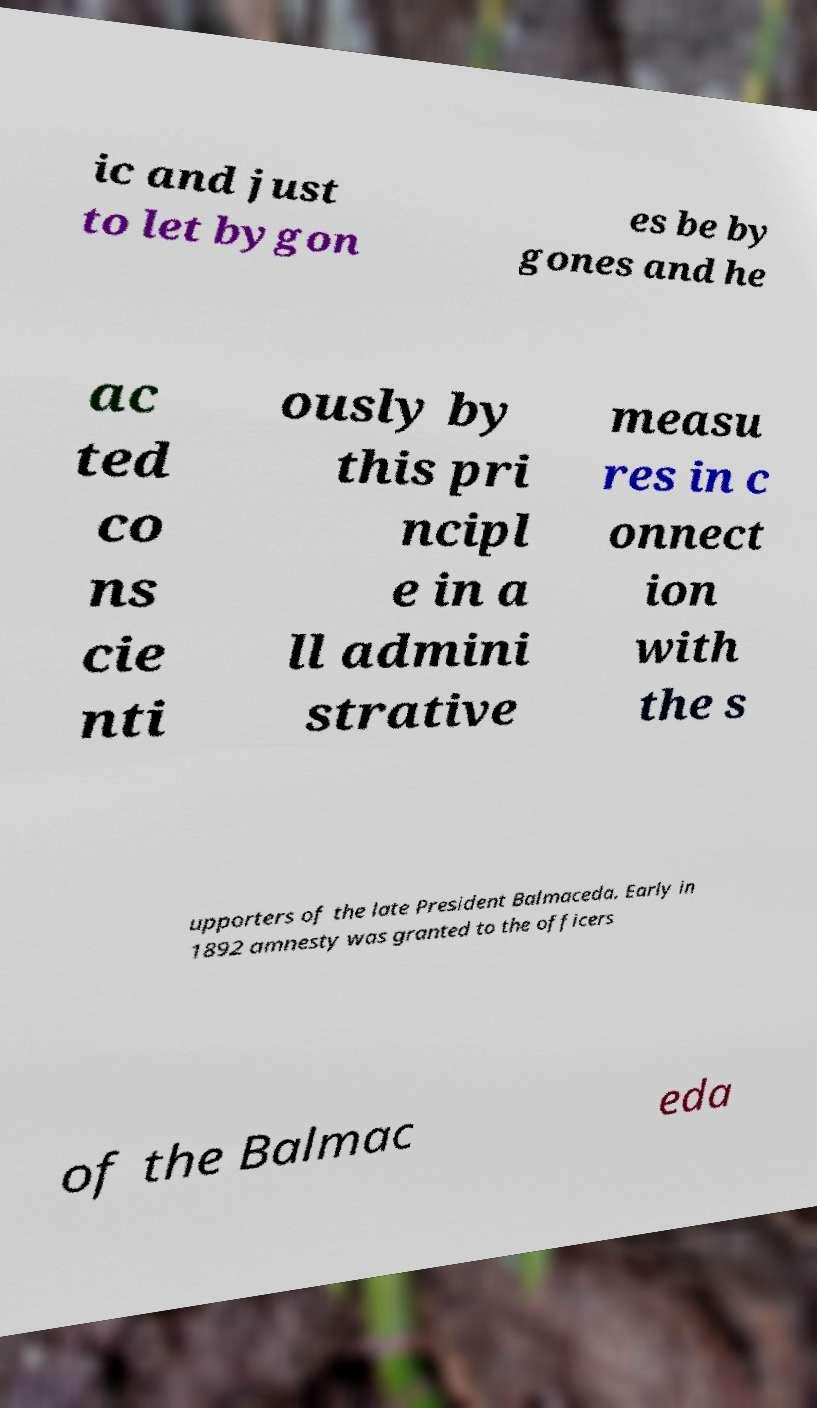Please read and relay the text visible in this image. What does it say? ic and just to let bygon es be by gones and he ac ted co ns cie nti ously by this pri ncipl e in a ll admini strative measu res in c onnect ion with the s upporters of the late President Balmaceda. Early in 1892 amnesty was granted to the officers of the Balmac eda 